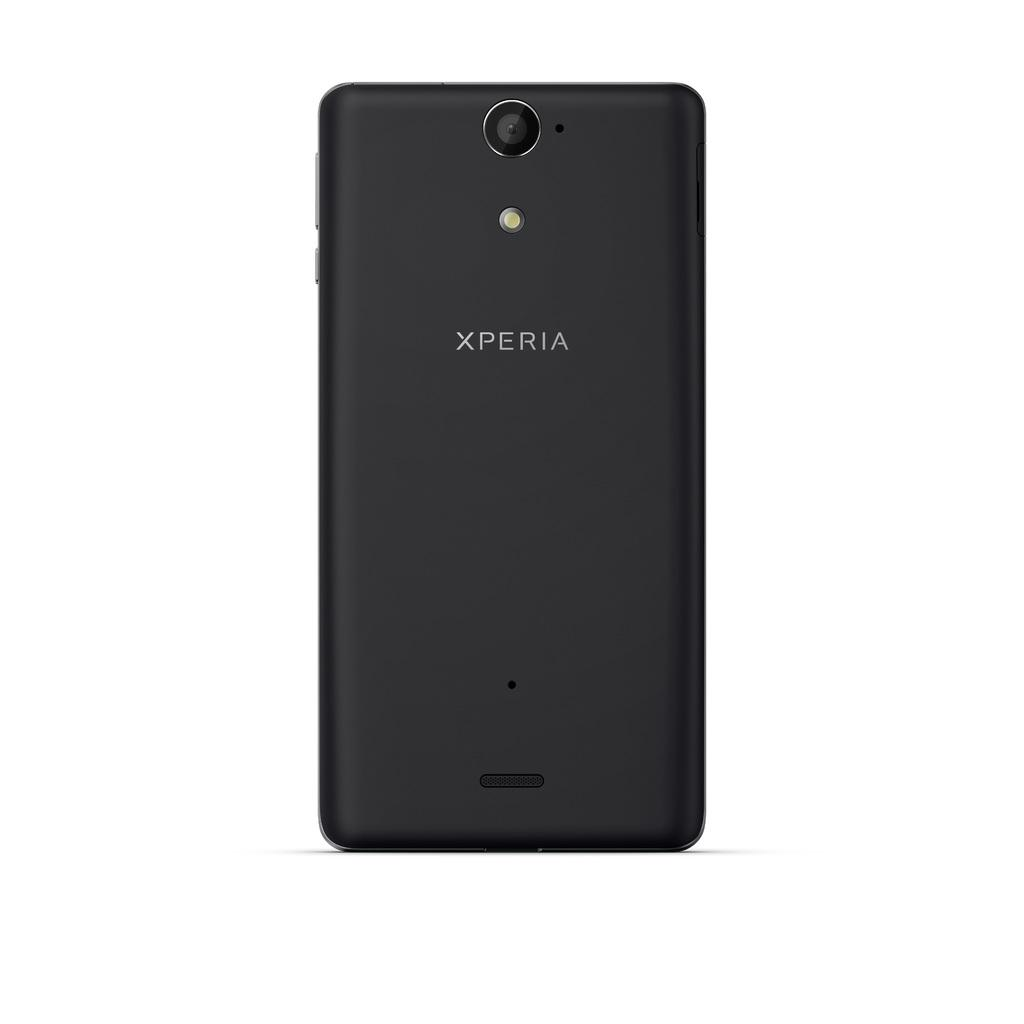<image>
Present a compact description of the photo's key features. A black xperia phone against a white back drop. 